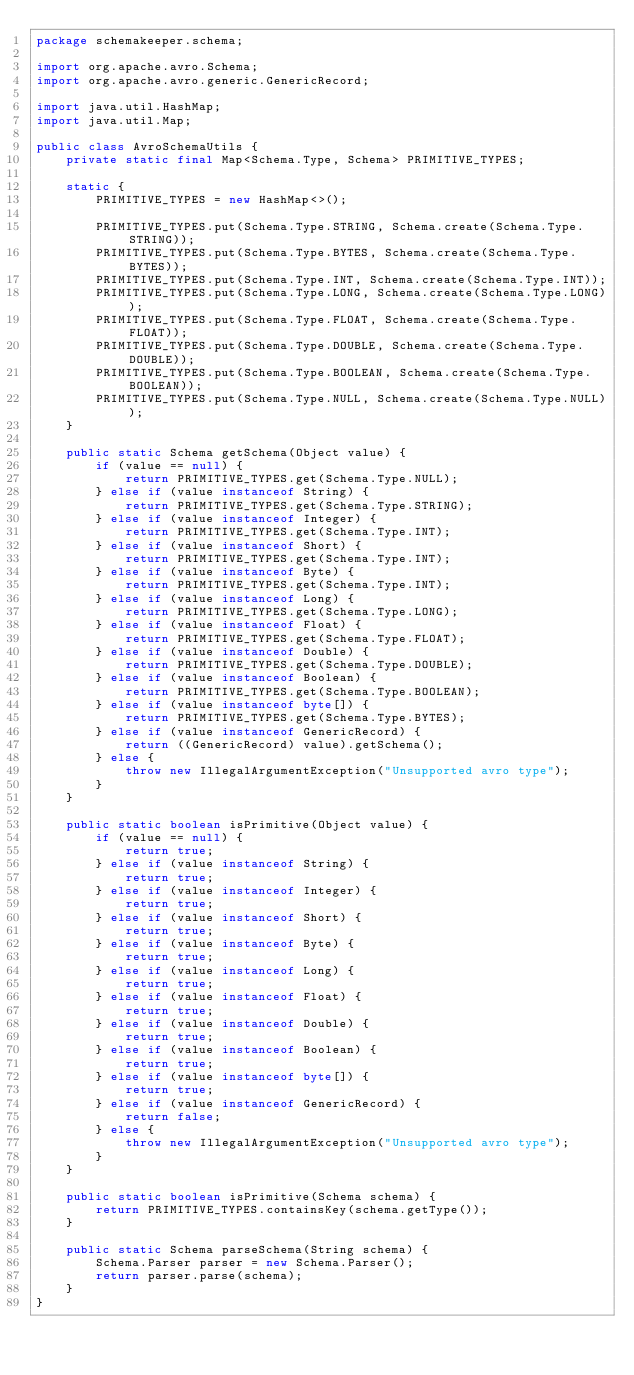Convert code to text. <code><loc_0><loc_0><loc_500><loc_500><_Java_>package schemakeeper.schema;

import org.apache.avro.Schema;
import org.apache.avro.generic.GenericRecord;

import java.util.HashMap;
import java.util.Map;

public class AvroSchemaUtils {
    private static final Map<Schema.Type, Schema> PRIMITIVE_TYPES;

    static {
        PRIMITIVE_TYPES = new HashMap<>();

        PRIMITIVE_TYPES.put(Schema.Type.STRING, Schema.create(Schema.Type.STRING));
        PRIMITIVE_TYPES.put(Schema.Type.BYTES, Schema.create(Schema.Type.BYTES));
        PRIMITIVE_TYPES.put(Schema.Type.INT, Schema.create(Schema.Type.INT));
        PRIMITIVE_TYPES.put(Schema.Type.LONG, Schema.create(Schema.Type.LONG));
        PRIMITIVE_TYPES.put(Schema.Type.FLOAT, Schema.create(Schema.Type.FLOAT));
        PRIMITIVE_TYPES.put(Schema.Type.DOUBLE, Schema.create(Schema.Type.DOUBLE));
        PRIMITIVE_TYPES.put(Schema.Type.BOOLEAN, Schema.create(Schema.Type.BOOLEAN));
        PRIMITIVE_TYPES.put(Schema.Type.NULL, Schema.create(Schema.Type.NULL));
    }

    public static Schema getSchema(Object value) {
        if (value == null) {
            return PRIMITIVE_TYPES.get(Schema.Type.NULL);
        } else if (value instanceof String) {
            return PRIMITIVE_TYPES.get(Schema.Type.STRING);
        } else if (value instanceof Integer) {
            return PRIMITIVE_TYPES.get(Schema.Type.INT);
        } else if (value instanceof Short) {
            return PRIMITIVE_TYPES.get(Schema.Type.INT);
        } else if (value instanceof Byte) {
            return PRIMITIVE_TYPES.get(Schema.Type.INT);
        } else if (value instanceof Long) {
            return PRIMITIVE_TYPES.get(Schema.Type.LONG);
        } else if (value instanceof Float) {
            return PRIMITIVE_TYPES.get(Schema.Type.FLOAT);
        } else if (value instanceof Double) {
            return PRIMITIVE_TYPES.get(Schema.Type.DOUBLE);
        } else if (value instanceof Boolean) {
            return PRIMITIVE_TYPES.get(Schema.Type.BOOLEAN);
        } else if (value instanceof byte[]) {
            return PRIMITIVE_TYPES.get(Schema.Type.BYTES);
        } else if (value instanceof GenericRecord) {
            return ((GenericRecord) value).getSchema();
        } else {
            throw new IllegalArgumentException("Unsupported avro type");
        }
    }

    public static boolean isPrimitive(Object value) {
        if (value == null) {
            return true;
        } else if (value instanceof String) {
            return true;
        } else if (value instanceof Integer) {
            return true;
        } else if (value instanceof Short) {
            return true;
        } else if (value instanceof Byte) {
            return true;
        } else if (value instanceof Long) {
            return true;
        } else if (value instanceof Float) {
            return true;
        } else if (value instanceof Double) {
            return true;
        } else if (value instanceof Boolean) {
            return true;
        } else if (value instanceof byte[]) {
            return true;
        } else if (value instanceof GenericRecord) {
            return false;
        } else {
            throw new IllegalArgumentException("Unsupported avro type");
        }
    }

    public static boolean isPrimitive(Schema schema) {
        return PRIMITIVE_TYPES.containsKey(schema.getType());
    }

    public static Schema parseSchema(String schema) {
        Schema.Parser parser = new Schema.Parser();
        return parser.parse(schema);
    }
}</code> 